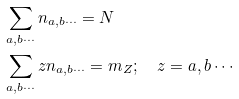Convert formula to latex. <formula><loc_0><loc_0><loc_500><loc_500>& \sum _ { a , b \cdots } n _ { a , b \cdots } = N \\ & \sum _ { a , b \cdots } z n _ { a , b \cdots } = m _ { Z } ; \quad z = a , b \cdots</formula> 